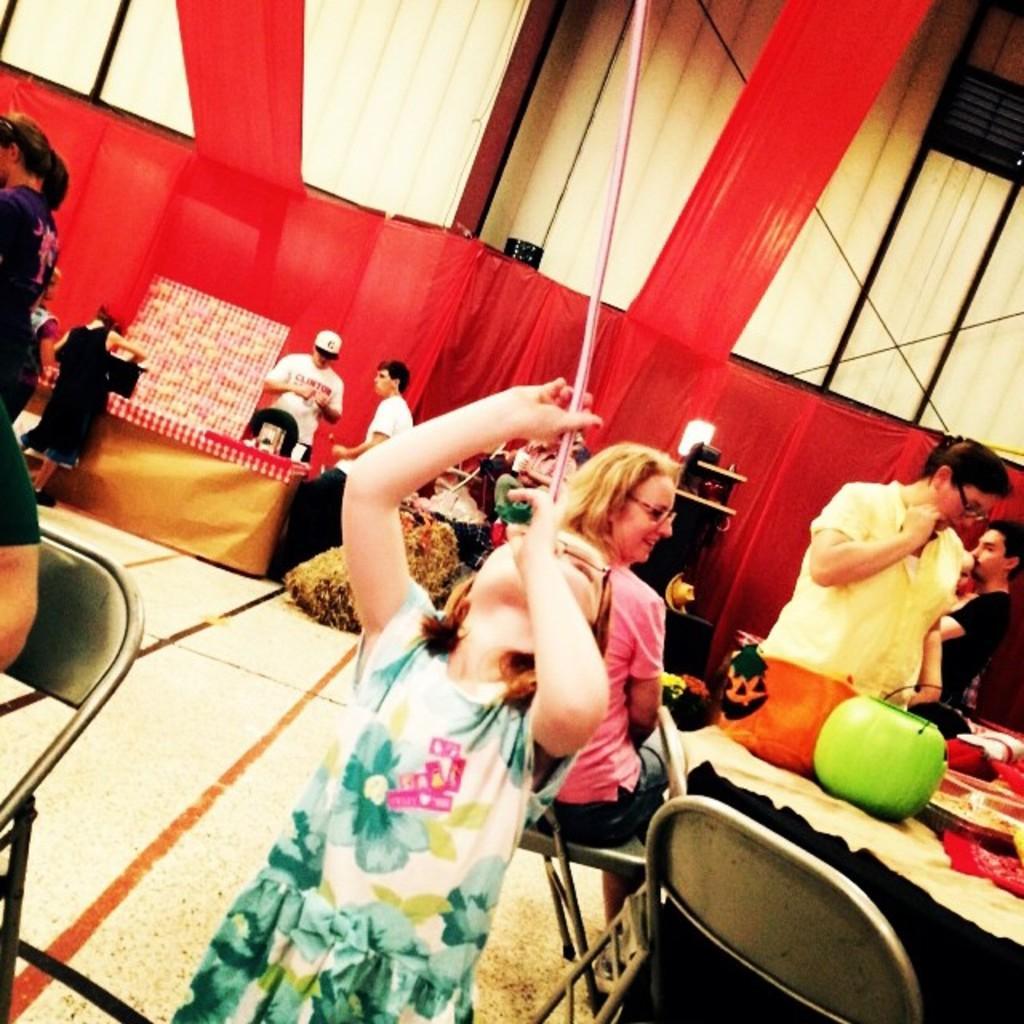In one or two sentences, can you explain what this image depicts? In the image there are few persons sitting and standing around table with pumpkins on it, in the back there is red color wall with few persons standing in front of it. 